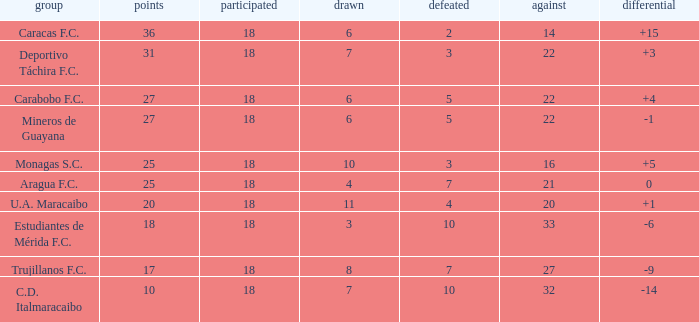What is the total score of all teams with against scores fewer than 14 points? None. 